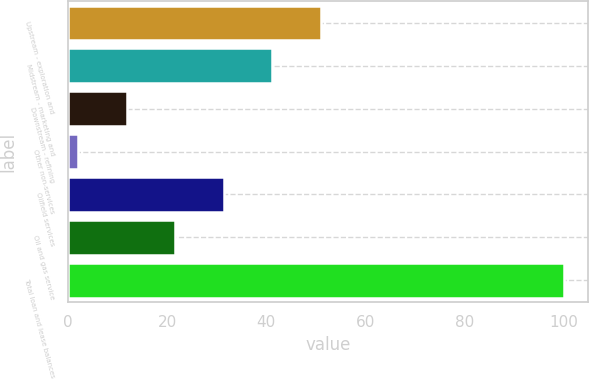Convert chart. <chart><loc_0><loc_0><loc_500><loc_500><bar_chart><fcel>Upstream - exploration and<fcel>Midstream - marketing and<fcel>Downstream - refining<fcel>Other non-services<fcel>Oilfield services<fcel>Oil and gas service<fcel>Total loan and lease balances<nl><fcel>51<fcel>41.2<fcel>11.8<fcel>2<fcel>31.4<fcel>21.6<fcel>100<nl></chart> 